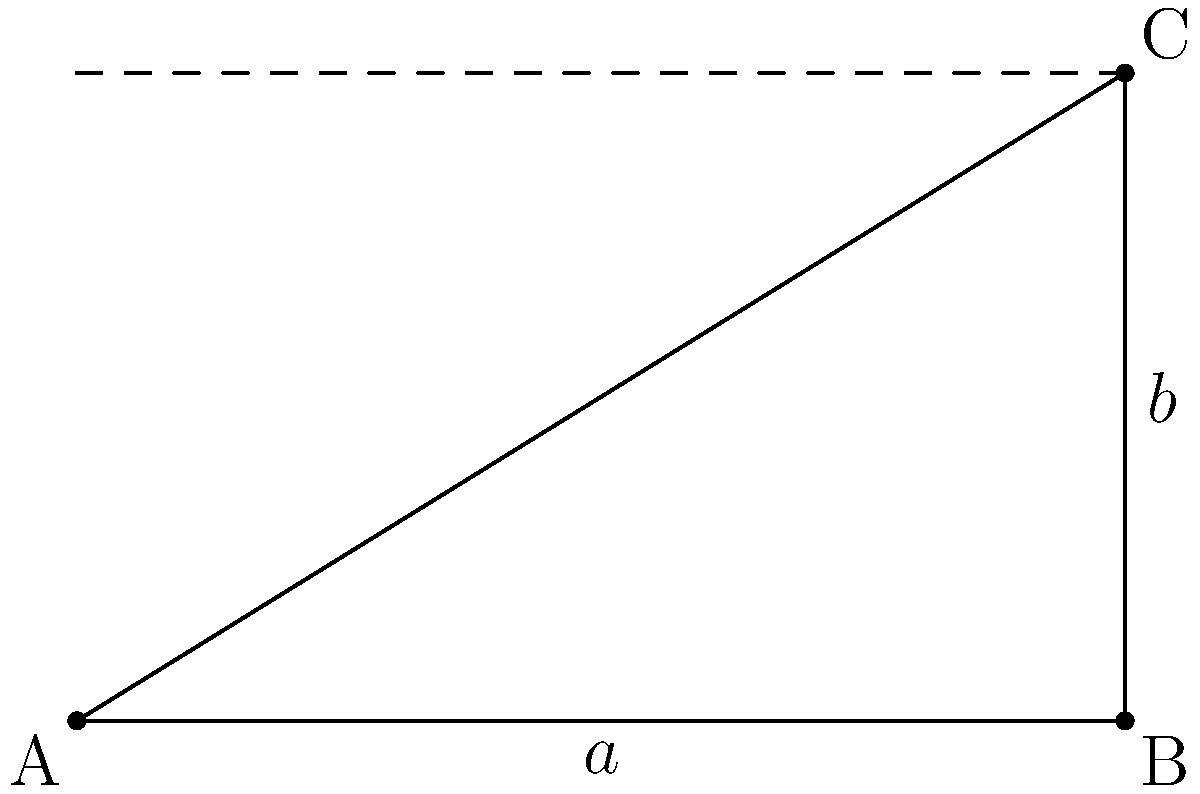In logo design, the golden ratio is often used to create aesthetically pleasing proportions. Given a rectangle with width $a$ and height $b$, as shown in the diagram, what is the formula for calculating the golden ratio? Express your answer in terms of $a$ and $b$. To calculate the golden ratio in logo design:

1. The golden ratio is approximately 1.618, often denoted by the Greek letter phi (φ).

2. In a rectangle, the golden ratio is achieved when the ratio of the longer side to the shorter side is equal to the ratio of the sum of both sides to the longer side.

3. In this case, $a$ is the longer side and $b$ is the shorter side.

4. The golden ratio formula can be expressed as:

   $$\frac{a}{b} = \frac{a + b}{a}$$

5. This equation represents the proportion that creates the aesthetically pleasing golden rectangle often used in logo design.

6. To use this in practice, designers would typically set one dimension (e.g., width) and calculate the other using this ratio to ensure their logo adheres to the golden proportion.
Answer: $$\frac{a}{b} = \frac{a + b}{a}$$ 